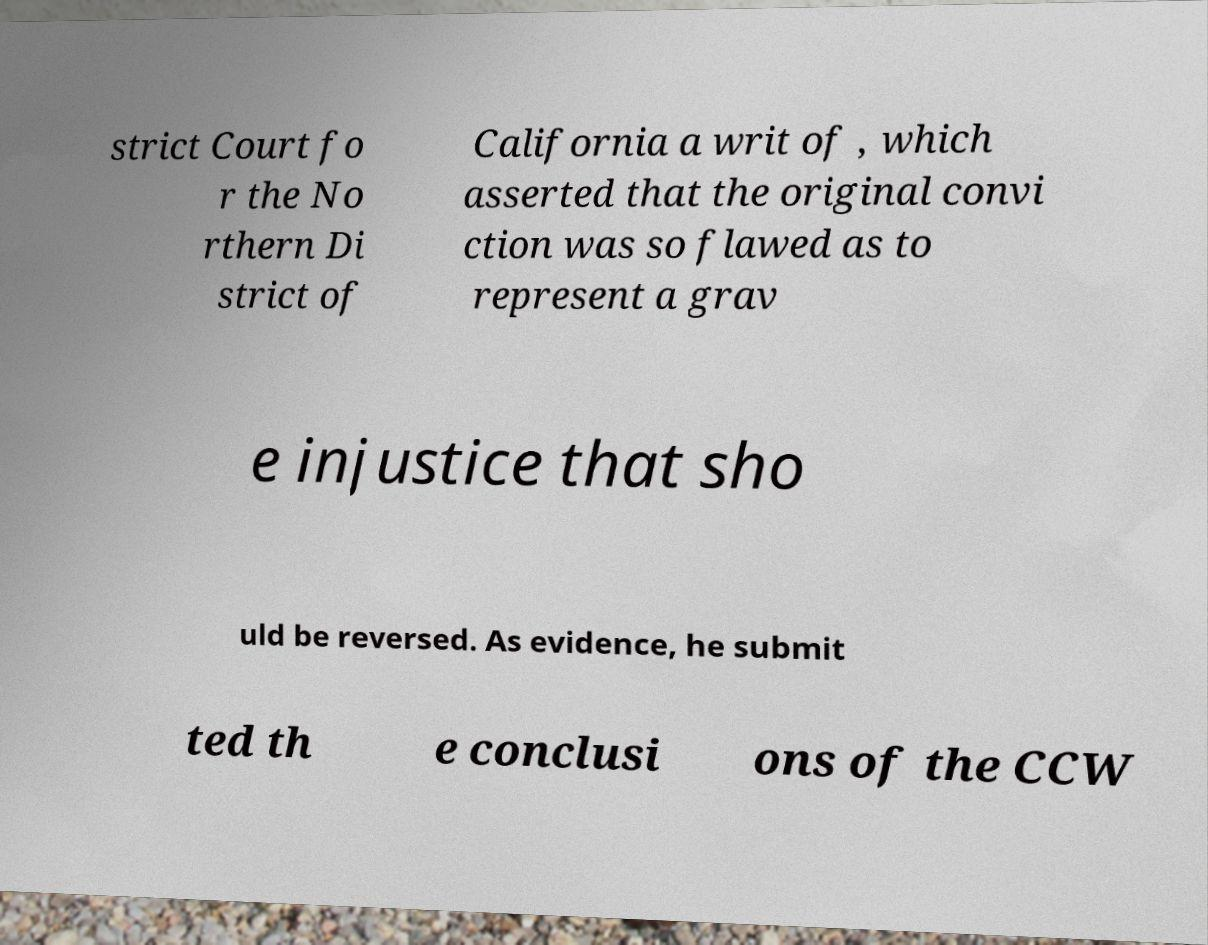There's text embedded in this image that I need extracted. Can you transcribe it verbatim? strict Court fo r the No rthern Di strict of California a writ of , which asserted that the original convi ction was so flawed as to represent a grav e injustice that sho uld be reversed. As evidence, he submit ted th e conclusi ons of the CCW 